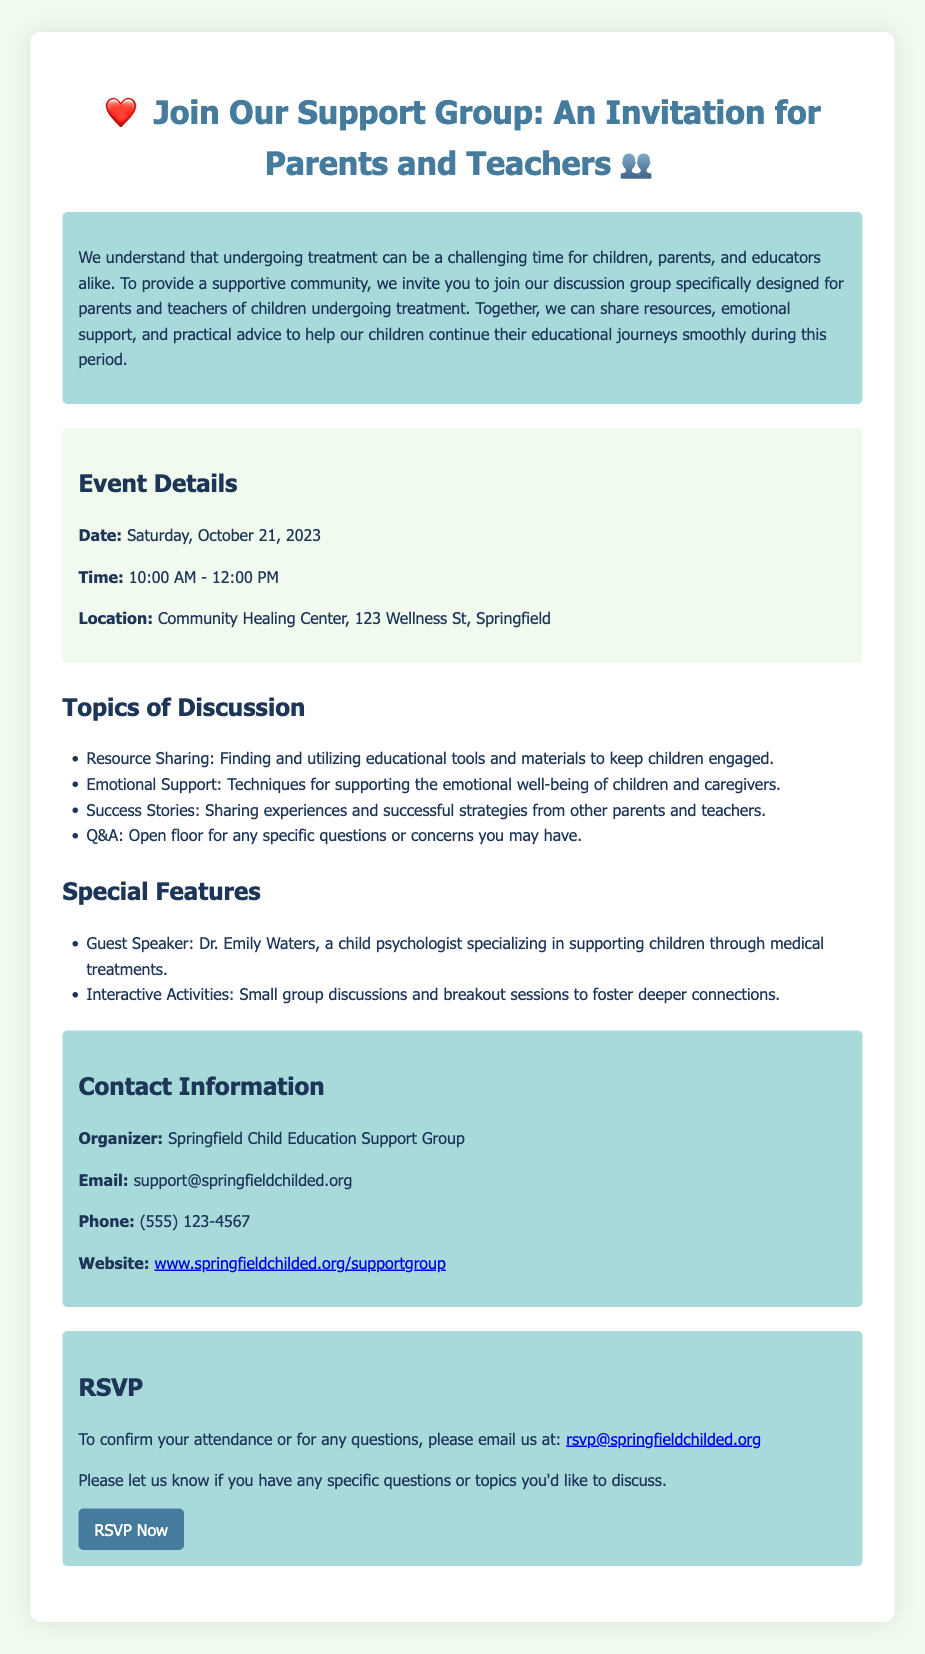What is the date of the event? The date of the event is specified in the document, which is Saturday, October 21, 2023.
Answer: Saturday, October 21, 2023 What time does the event start? The time when the event starts is mentioned in the document as 10:00 AM.
Answer: 10:00 AM Where is the event located? The document provides the location of the event, which is Community Healing Center, 123 Wellness St, Springfield.
Answer: Community Healing Center, 123 Wellness St, Springfield Who is the guest speaker? The document lists the guest speaker as Dr. Emily Waters, who specializes in supporting children through medical treatments.
Answer: Dr. Emily Waters What type of support is the group focused on? The document highlights that the group is designed for emotional support and sharing resources for children undergoing treatment.
Answer: Emotional support and resources What topics are discussed in the group? The document details topics of discussion, including resource sharing, emotional support, and success stories.
Answer: Resource sharing, emotional support, and success stories What is the contact email for RSVPs? The contact email for RSVPs is mentioned in the document as rsvp@springfieldchilded.org.
Answer: rsvp@springfieldchilded.org What is the duration of the event? The document states the event is scheduled from 10:00 AM to 12:00 PM, indicating a duration of 2 hours.
Answer: 2 hours 